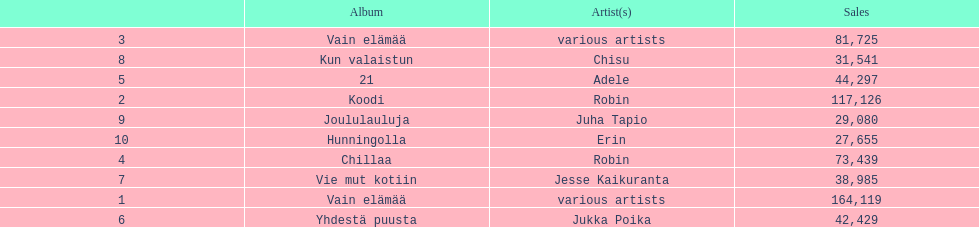Which album has the highest number of sales but doesn't have a designated artist? Vain elämää. I'm looking to parse the entire table for insights. Could you assist me with that? {'header': ['', 'Album', 'Artist(s)', 'Sales'], 'rows': [['3', 'Vain elämää', 'various artists', '81,725'], ['8', 'Kun valaistun', 'Chisu', '31,541'], ['5', '21', 'Adele', '44,297'], ['2', 'Koodi', 'Robin', '117,126'], ['9', 'Joululauluja', 'Juha Tapio', '29,080'], ['10', 'Hunningolla', 'Erin', '27,655'], ['4', 'Chillaa', 'Robin', '73,439'], ['7', 'Vie mut kotiin', 'Jesse Kaikuranta', '38,985'], ['1', 'Vain elämää', 'various artists', '164,119'], ['6', 'Yhdestä puusta', 'Jukka Poika', '42,429']]} 